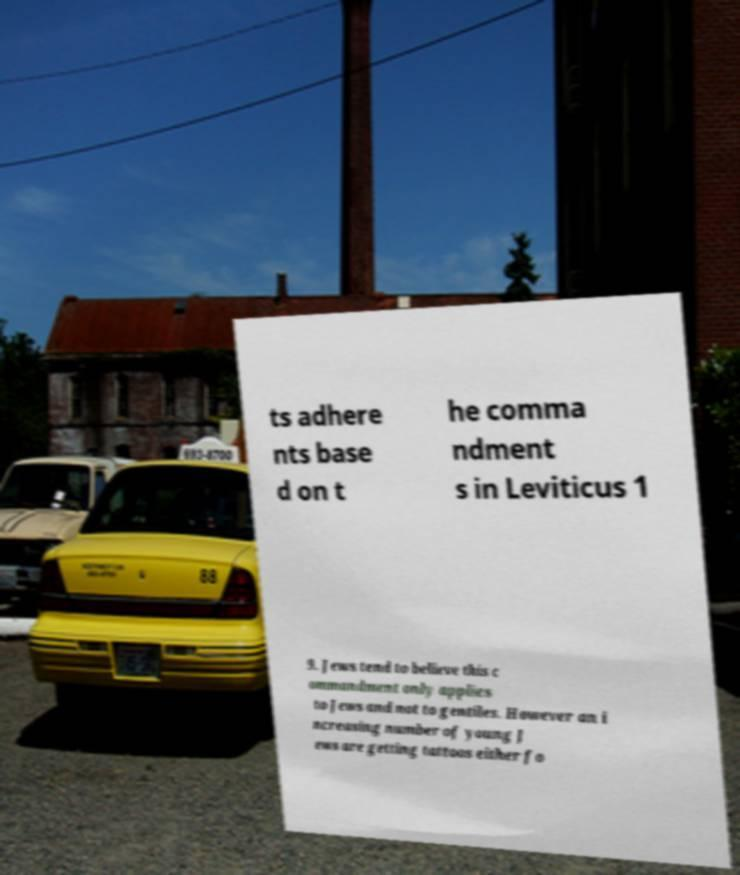For documentation purposes, I need the text within this image transcribed. Could you provide that? ts adhere nts base d on t he comma ndment s in Leviticus 1 9. Jews tend to believe this c ommandment only applies to Jews and not to gentiles. However an i ncreasing number of young J ews are getting tattoos either fo 